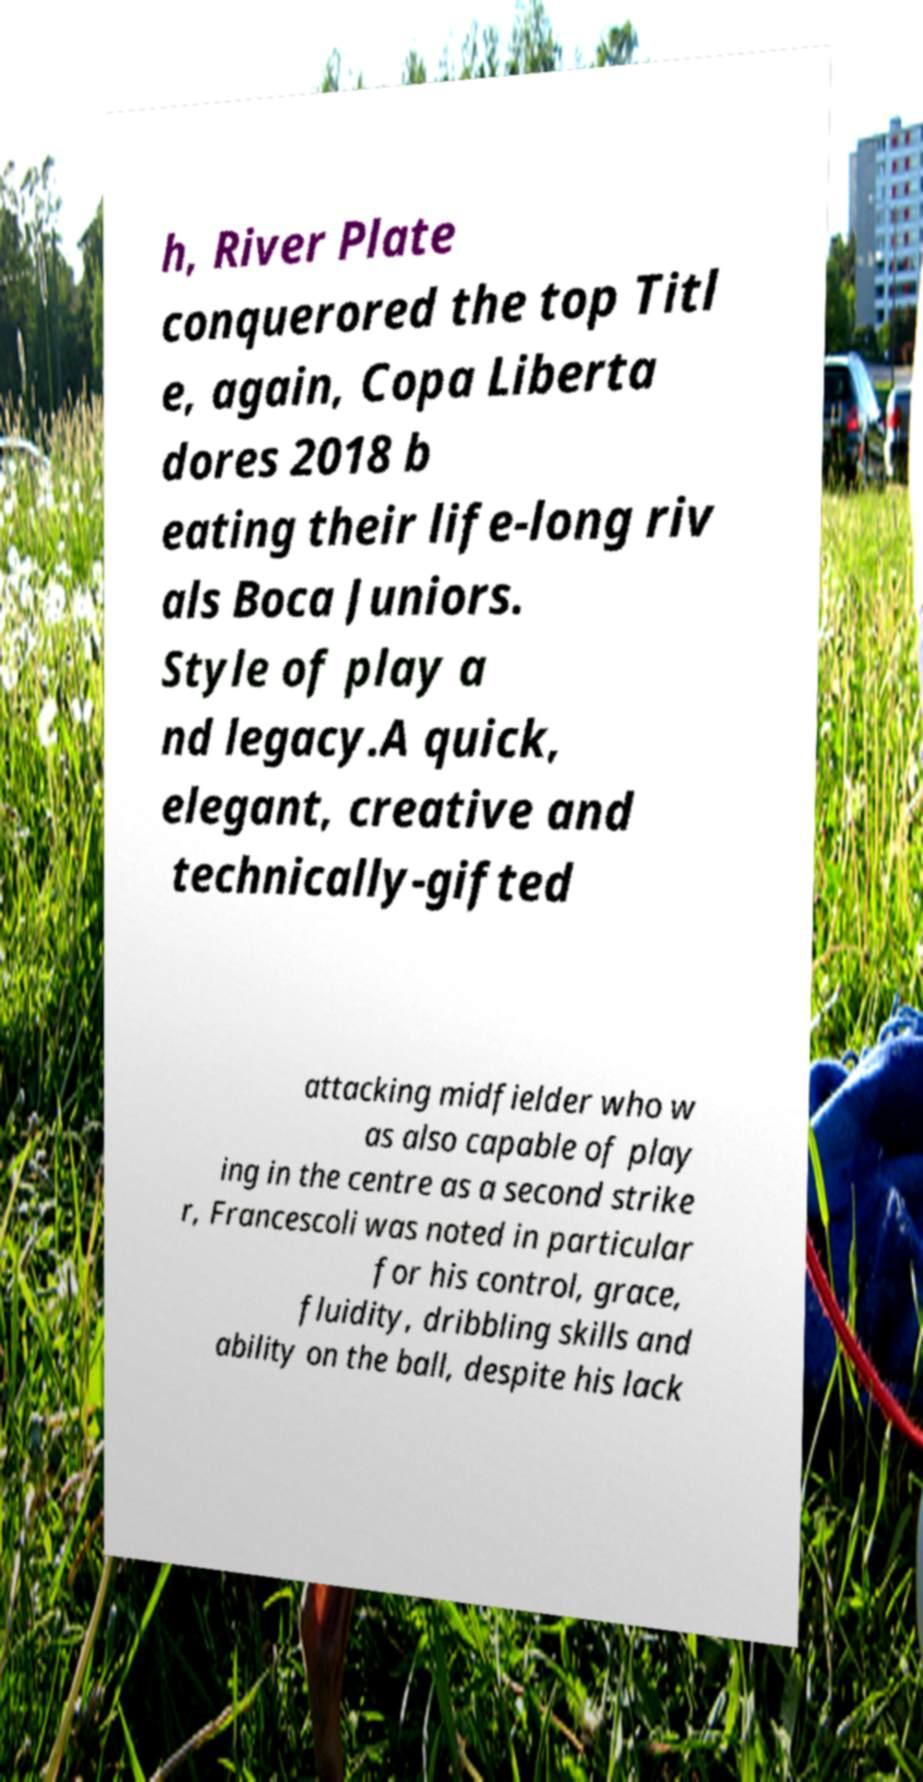There's text embedded in this image that I need extracted. Can you transcribe it verbatim? h, River Plate conquerored the top Titl e, again, Copa Liberta dores 2018 b eating their life-long riv als Boca Juniors. Style of play a nd legacy.A quick, elegant, creative and technically-gifted attacking midfielder who w as also capable of play ing in the centre as a second strike r, Francescoli was noted in particular for his control, grace, fluidity, dribbling skills and ability on the ball, despite his lack 